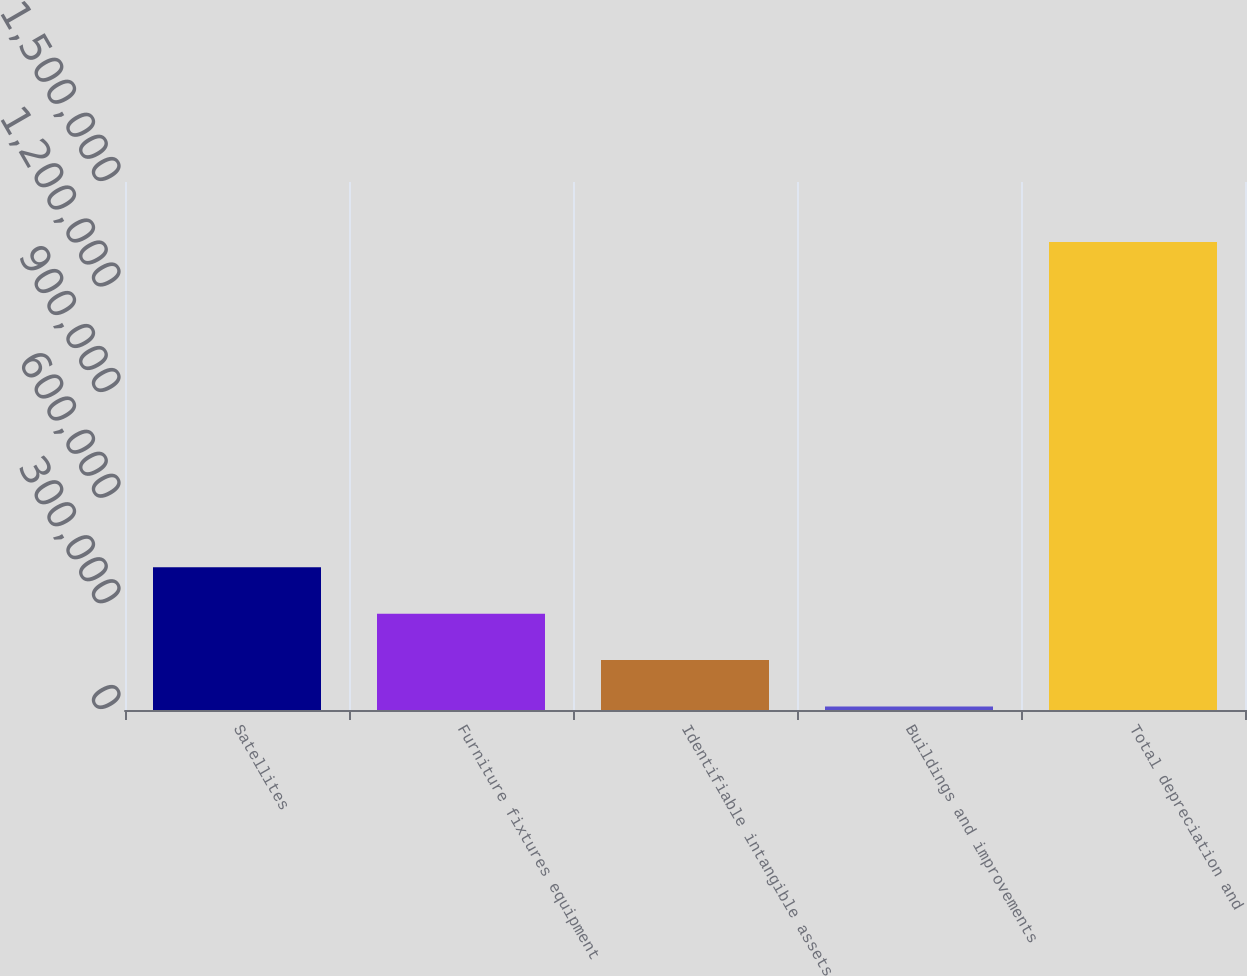Convert chart to OTSL. <chart><loc_0><loc_0><loc_500><loc_500><bar_chart><fcel>Satellites<fcel>Furniture fixtures equipment<fcel>Identifiable intangible assets<fcel>Buildings and improvements<fcel>Total depreciation and<nl><fcel>405670<fcel>273707<fcel>141744<fcel>9781<fcel>1.32941e+06<nl></chart> 